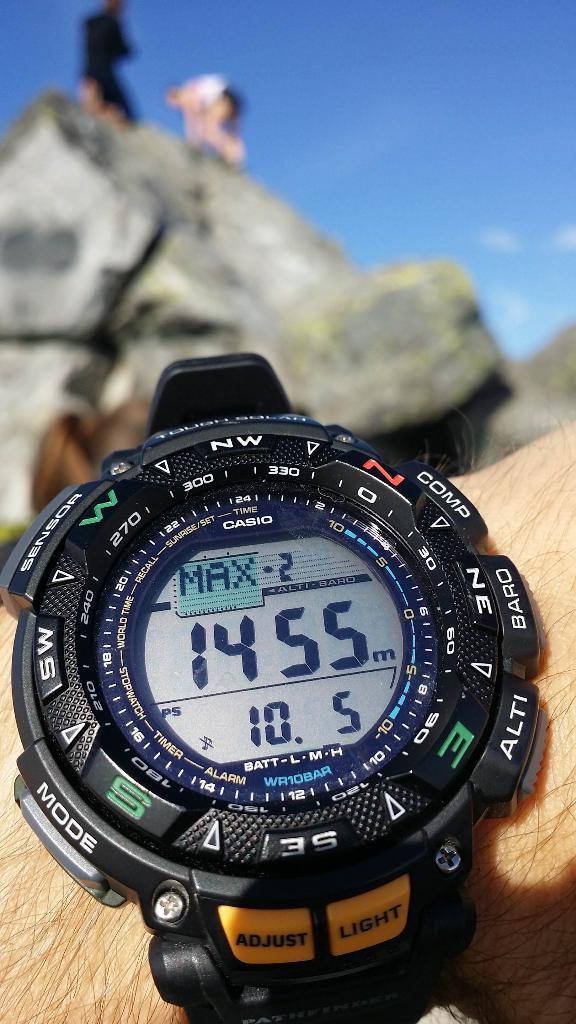Provide a one-sentence caption for the provided image. A black watch has buttons for adjust and light at the bottom. 